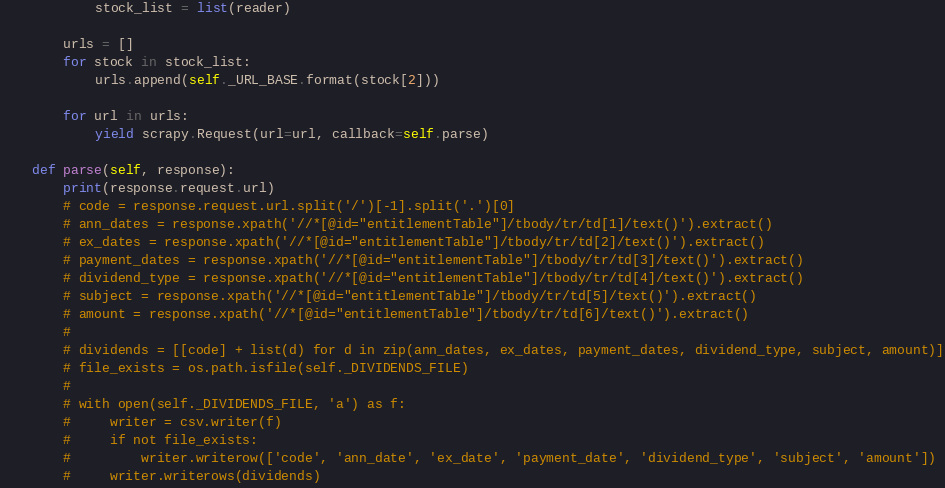Convert code to text. <code><loc_0><loc_0><loc_500><loc_500><_Python_>            stock_list = list(reader)

        urls = []
        for stock in stock_list:
            urls.append(self._URL_BASE.format(stock[2]))

        for url in urls:
            yield scrapy.Request(url=url, callback=self.parse)

    def parse(self, response):
        print(response.request.url)
        # code = response.request.url.split('/')[-1].split('.')[0]
        # ann_dates = response.xpath('//*[@id="entitlementTable"]/tbody/tr/td[1]/text()').extract()
        # ex_dates = response.xpath('//*[@id="entitlementTable"]/tbody/tr/td[2]/text()').extract()
        # payment_dates = response.xpath('//*[@id="entitlementTable"]/tbody/tr/td[3]/text()').extract()
        # dividend_type = response.xpath('//*[@id="entitlementTable"]/tbody/tr/td[4]/text()').extract()
        # subject = response.xpath('//*[@id="entitlementTable"]/tbody/tr/td[5]/text()').extract()
        # amount = response.xpath('//*[@id="entitlementTable"]/tbody/tr/td[6]/text()').extract()
        #
        # dividends = [[code] + list(d) for d in zip(ann_dates, ex_dates, payment_dates, dividend_type, subject, amount)]
        # file_exists = os.path.isfile(self._DIVIDENDS_FILE)
        #
        # with open(self._DIVIDENDS_FILE, 'a') as f:
        #     writer = csv.writer(f)
        #     if not file_exists:
        #         writer.writerow(['code', 'ann_date', 'ex_date', 'payment_date', 'dividend_type', 'subject', 'amount'])
        #     writer.writerows(dividends)
</code> 